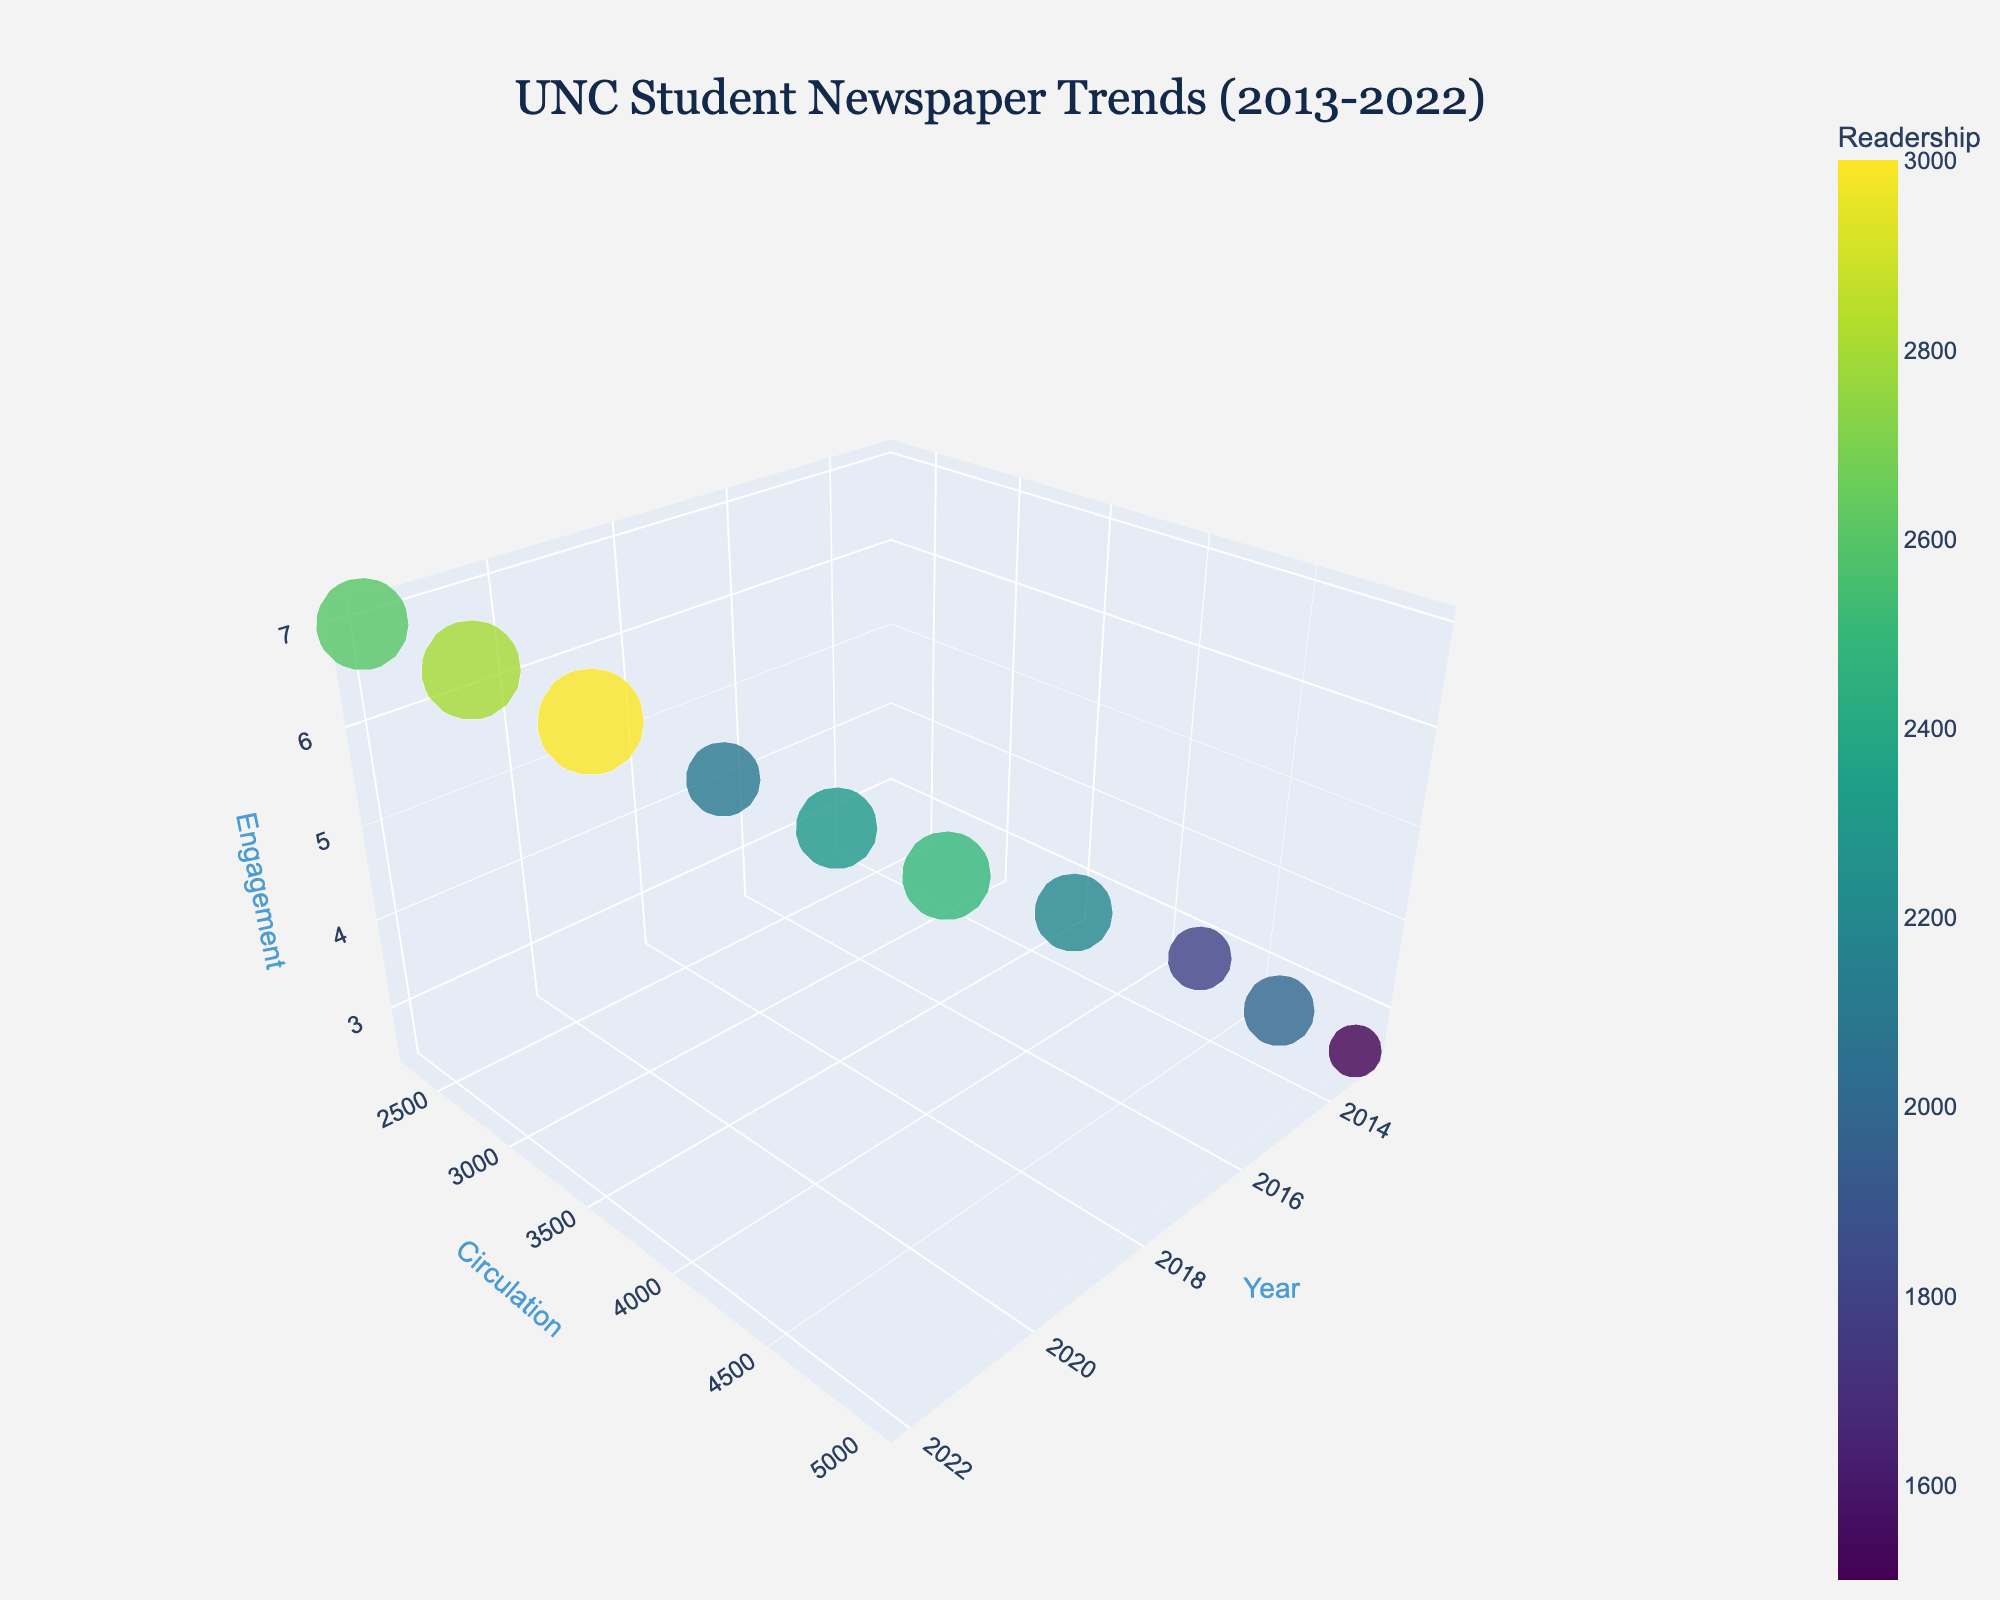What is the title of the 3D bubble chart? The title is typically displayed prominently at the top of the figure. In this case, the title is "UNC Student Newspaper Trends (2013-2022)" as specified in the code.
Answer: UNC Student Newspaper Trends (2013-2022) How does the readership trend change over the years? By examining the size and color of the bubbles over the years from 2013 to 2022, we can see that the bubbles generally decrease in size and lighten in color, indicating a decrease in readership.
Answer: Decreasing Which topic has the highest reader engagement? By looking at the z-axis (Engagement) and finding the highest bubble point, "Career Development" in 2022 has the highest engagement value of 7.0.
Answer: Career Development What year had the highest circulation number? The y-axis represents the circulation numbers. The highest point on the y-axis corresponds to the year 2013, with a circulation number of 5000.
Answer: 2013 Compare the readership in 2017 to 2020. Which year had higher readership, and by how much? In 2017, the readership is 2500, while in 2020, it is 3000. Subtracting 2500 from 3000 shows that 2020 had a higher readership by 500.
Answer: 2020, by 500 What is the relationship between circulation and engagement over the years? By observing the trend of the bubbles in both the y-axis (Circulation) and the z-axis (Engagement), we see that as circulation decreases, engagement generally increases.
Answer: Inversely related Between which years did the biggest drop in circulation occur? Comparing the distances between points on the y-axis (Circulation), the biggest drop occurs between 2019 (3200) and 2020 (2800), a drop of 400.
Answer: 2019-2020 How does the topic of "COVID-19 Impact" compare in terms of engagement to "Campus Politics"? "COVID-19 Impact" in 2020 has an engagement score of 6.0, whereas "Campus Politics" in 2013 has an engagement score of 2.5. Thus, "COVID-19 Impact" had significantly higher engagement.
Answer: COVID-19 Impact had higher engagement Which year had the smallest readership, and what was it? Identifying the smallest bubble, which represents the lowest readership, it occurs in 2022 with a readership of 2300.
Answer: 2022, 2300 What trend do you observe in the variety of topics covered over the years? Observing the text labels from 2013 through 2022, topics vary widely from "Campus Politics" to "Career Development," indicating a broadening of topical variety.
Answer: Increasing variety 